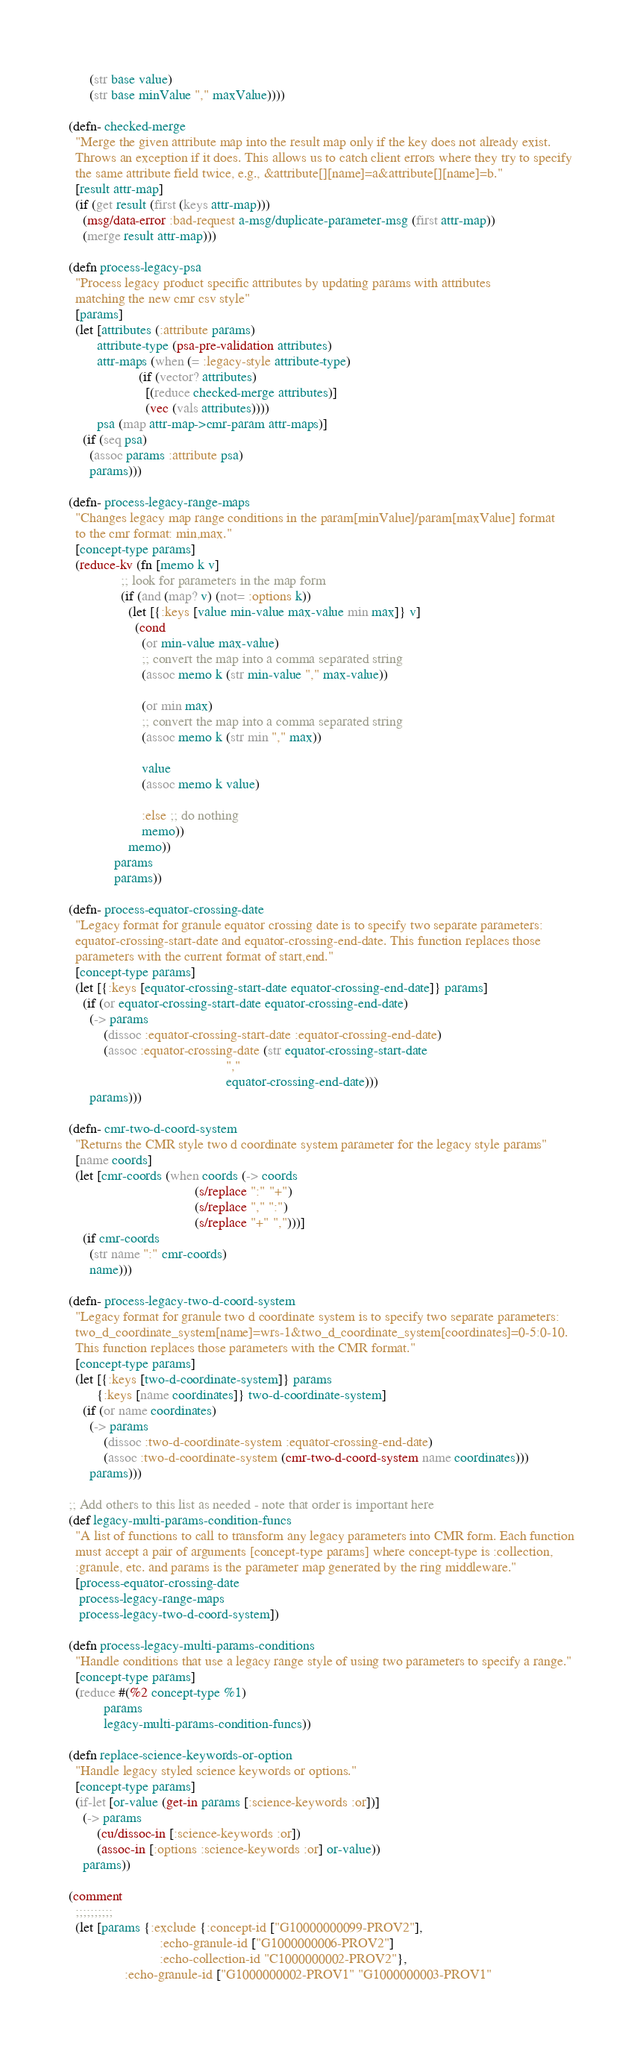<code> <loc_0><loc_0><loc_500><loc_500><_Clojure_>      (str base value)
      (str base minValue "," maxValue))))

(defn- checked-merge
  "Merge the given attribute map into the result map only if the key does not already exist.
  Throws an exception if it does. This allows us to catch client errors where they try to specify
  the same attribute field twice, e.g., &attribute[][name]=a&attribute[][name]=b."
  [result attr-map]
  (if (get result (first (keys attr-map)))
    (msg/data-error :bad-request a-msg/duplicate-parameter-msg (first attr-map))
    (merge result attr-map)))

(defn process-legacy-psa
  "Process legacy product specific attributes by updating params with attributes
  matching the new cmr csv style"
  [params]
  (let [attributes (:attribute params)
        attribute-type (psa-pre-validation attributes)
        attr-maps (when (= :legacy-style attribute-type)
                    (if (vector? attributes)
                      [(reduce checked-merge attributes)]
                      (vec (vals attributes))))
        psa (map attr-map->cmr-param attr-maps)]
    (if (seq psa)
      (assoc params :attribute psa)
      params)))

(defn- process-legacy-range-maps
  "Changes legacy map range conditions in the param[minValue]/param[maxValue] format
  to the cmr format: min,max."
  [concept-type params]
  (reduce-kv (fn [memo k v]
               ;; look for parameters in the map form
               (if (and (map? v) (not= :options k))
                 (let [{:keys [value min-value max-value min max]} v]
                   (cond
                     (or min-value max-value)
                     ;; convert the map into a comma separated string
                     (assoc memo k (str min-value "," max-value))

                     (or min max)
                     ;; convert the map into a comma separated string
                     (assoc memo k (str min "," max))

                     value
                     (assoc memo k value)

                     :else ;; do nothing
                     memo))
                 memo))
             params
             params))

(defn- process-equator-crossing-date
  "Legacy format for granule equator crossing date is to specify two separate parameters:
  equator-crossing-start-date and equator-crossing-end-date. This function replaces those
  parameters with the current format of start,end."
  [concept-type params]
  (let [{:keys [equator-crossing-start-date equator-crossing-end-date]} params]
    (if (or equator-crossing-start-date equator-crossing-end-date)
      (-> params
          (dissoc :equator-crossing-start-date :equator-crossing-end-date)
          (assoc :equator-crossing-date (str equator-crossing-start-date
                                             ","
                                             equator-crossing-end-date)))
      params)))

(defn- cmr-two-d-coord-system
  "Returns the CMR style two d coordinate system parameter for the legacy style params"
  [name coords]
  (let [cmr-coords (when coords (-> coords
                                    (s/replace ":" "+")
                                    (s/replace "," ":")
                                    (s/replace "+" ",")))]
    (if cmr-coords
      (str name ":" cmr-coords)
      name)))

(defn- process-legacy-two-d-coord-system
  "Legacy format for granule two d coordinate system is to specify two separate parameters:
  two_d_coordinate_system[name]=wrs-1&two_d_coordinate_system[coordinates]=0-5:0-10.
  This function replaces those parameters with the CMR format."
  [concept-type params]
  (let [{:keys [two-d-coordinate-system]} params
        {:keys [name coordinates]} two-d-coordinate-system]
    (if (or name coordinates)
      (-> params
          (dissoc :two-d-coordinate-system :equator-crossing-end-date)
          (assoc :two-d-coordinate-system (cmr-two-d-coord-system name coordinates)))
      params)))

;; Add others to this list as needed - note that order is important here
(def legacy-multi-params-condition-funcs
  "A list of functions to call to transform any legacy parameters into CMR form. Each function
  must accept a pair of arguments [concept-type params] where concept-type is :collection,
  :granule, etc. and params is the parameter map generated by the ring middleware."
  [process-equator-crossing-date
   process-legacy-range-maps
   process-legacy-two-d-coord-system])

(defn process-legacy-multi-params-conditions
  "Handle conditions that use a legacy range style of using two parameters to specify a range."
  [concept-type params]
  (reduce #(%2 concept-type %1)
          params
          legacy-multi-params-condition-funcs))

(defn replace-science-keywords-or-option
  "Handle legacy styled science keywords or options."
  [concept-type params]
  (if-let [or-value (get-in params [:science-keywords :or])]
    (-> params
        (cu/dissoc-in [:science-keywords :or])
        (assoc-in [:options :science-keywords :or] or-value))
    params))

(comment
  ;;;;;;;;;;
  (let [params {:exclude {:concept-id ["G10000000099-PROV2"],
                          :echo-granule-id ["G1000000006-PROV2"]
                          :echo-collection-id "C1000000002-PROV2"},
                :echo-granule-id ["G1000000002-PROV1" "G1000000003-PROV1"</code> 